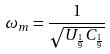Convert formula to latex. <formula><loc_0><loc_0><loc_500><loc_500>\omega _ { m } = \frac { 1 } { \sqrt { U _ { \frac { 1 } { 9 } } C _ { \frac { 1 } { 9 } } } }</formula> 